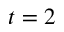Convert formula to latex. <formula><loc_0><loc_0><loc_500><loc_500>t = 2</formula> 